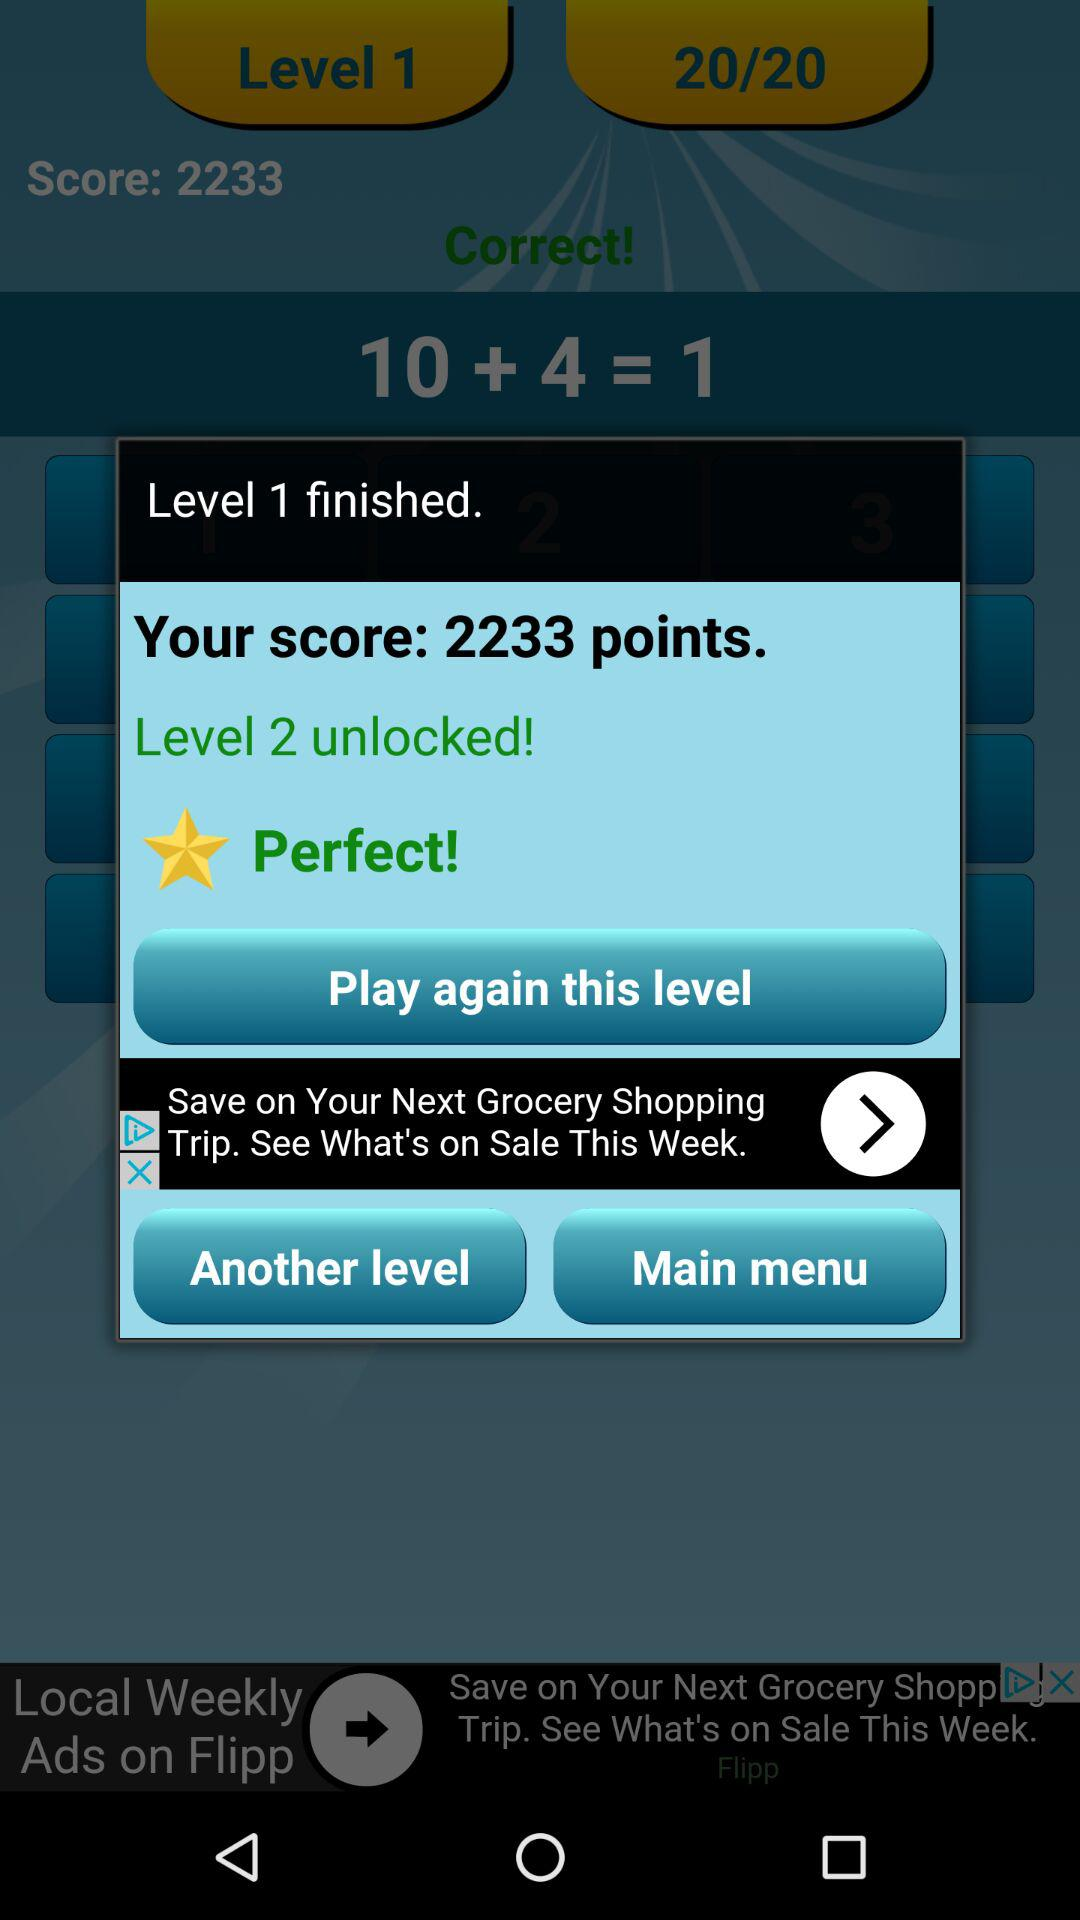How many levels have I unlocked?
Answer the question using a single word or phrase. 2 